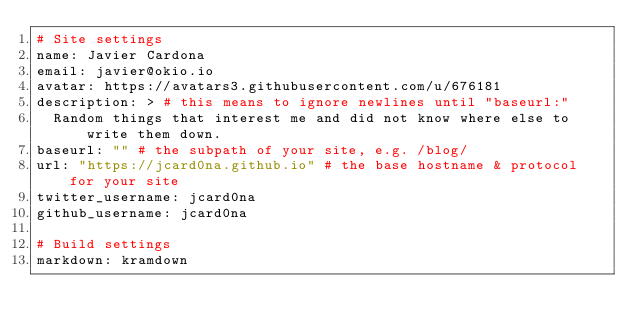Convert code to text. <code><loc_0><loc_0><loc_500><loc_500><_YAML_># Site settings
name: Javier Cardona
email: javier@okio.io
avatar: https://avatars3.githubusercontent.com/u/676181
description: > # this means to ignore newlines until "baseurl:"
  Random things that interest me and did not know where else to write them down. 
baseurl: "" # the subpath of your site, e.g. /blog/
url: "https://jcard0na.github.io" # the base hostname & protocol for your site
twitter_username: jcard0na
github_username: jcard0na

# Build settings
markdown: kramdown
</code> 